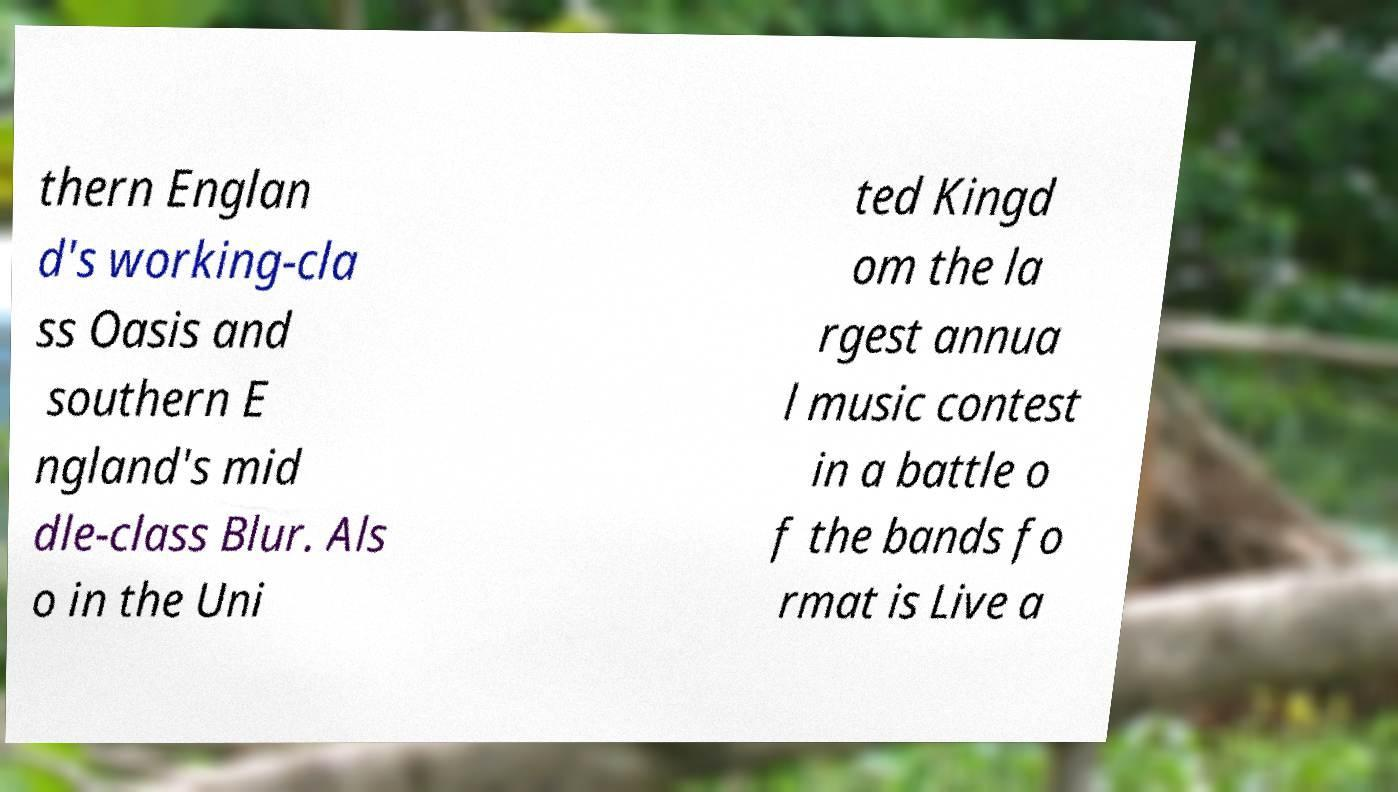For documentation purposes, I need the text within this image transcribed. Could you provide that? thern Englan d's working-cla ss Oasis and southern E ngland's mid dle-class Blur. Als o in the Uni ted Kingd om the la rgest annua l music contest in a battle o f the bands fo rmat is Live a 